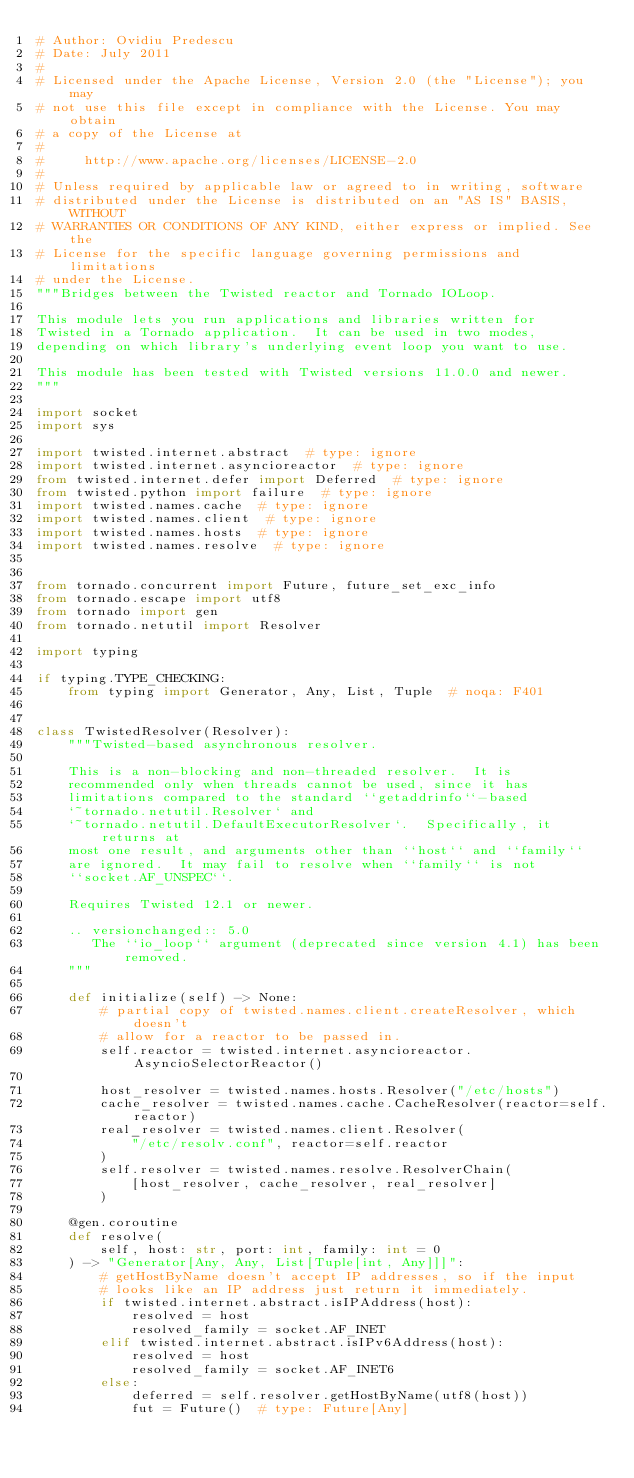<code> <loc_0><loc_0><loc_500><loc_500><_Python_># Author: Ovidiu Predescu
# Date: July 2011
#
# Licensed under the Apache License, Version 2.0 (the "License"); you may
# not use this file except in compliance with the License. You may obtain
# a copy of the License at
#
#     http://www.apache.org/licenses/LICENSE-2.0
#
# Unless required by applicable law or agreed to in writing, software
# distributed under the License is distributed on an "AS IS" BASIS, WITHOUT
# WARRANTIES OR CONDITIONS OF ANY KIND, either express or implied. See the
# License for the specific language governing permissions and limitations
# under the License.
"""Bridges between the Twisted reactor and Tornado IOLoop.

This module lets you run applications and libraries written for
Twisted in a Tornado application.  It can be used in two modes,
depending on which library's underlying event loop you want to use.

This module has been tested with Twisted versions 11.0.0 and newer.
"""

import socket
import sys

import twisted.internet.abstract  # type: ignore
import twisted.internet.asyncioreactor  # type: ignore
from twisted.internet.defer import Deferred  # type: ignore
from twisted.python import failure  # type: ignore
import twisted.names.cache  # type: ignore
import twisted.names.client  # type: ignore
import twisted.names.hosts  # type: ignore
import twisted.names.resolve  # type: ignore


from tornado.concurrent import Future, future_set_exc_info
from tornado.escape import utf8
from tornado import gen
from tornado.netutil import Resolver

import typing

if typing.TYPE_CHECKING:
    from typing import Generator, Any, List, Tuple  # noqa: F401


class TwistedResolver(Resolver):
    """Twisted-based asynchronous resolver.

    This is a non-blocking and non-threaded resolver.  It is
    recommended only when threads cannot be used, since it has
    limitations compared to the standard ``getaddrinfo``-based
    `~tornado.netutil.Resolver` and
    `~tornado.netutil.DefaultExecutorResolver`.  Specifically, it returns at
    most one result, and arguments other than ``host`` and ``family``
    are ignored.  It may fail to resolve when ``family`` is not
    ``socket.AF_UNSPEC``.

    Requires Twisted 12.1 or newer.

    .. versionchanged:: 5.0
       The ``io_loop`` argument (deprecated since version 4.1) has been removed.
    """

    def initialize(self) -> None:
        # partial copy of twisted.names.client.createResolver, which doesn't
        # allow for a reactor to be passed in.
        self.reactor = twisted.internet.asyncioreactor.AsyncioSelectorReactor()

        host_resolver = twisted.names.hosts.Resolver("/etc/hosts")
        cache_resolver = twisted.names.cache.CacheResolver(reactor=self.reactor)
        real_resolver = twisted.names.client.Resolver(
            "/etc/resolv.conf", reactor=self.reactor
        )
        self.resolver = twisted.names.resolve.ResolverChain(
            [host_resolver, cache_resolver, real_resolver]
        )

    @gen.coroutine
    def resolve(
        self, host: str, port: int, family: int = 0
    ) -> "Generator[Any, Any, List[Tuple[int, Any]]]":
        # getHostByName doesn't accept IP addresses, so if the input
        # looks like an IP address just return it immediately.
        if twisted.internet.abstract.isIPAddress(host):
            resolved = host
            resolved_family = socket.AF_INET
        elif twisted.internet.abstract.isIPv6Address(host):
            resolved = host
            resolved_family = socket.AF_INET6
        else:
            deferred = self.resolver.getHostByName(utf8(host))
            fut = Future()  # type: Future[Any]</code> 